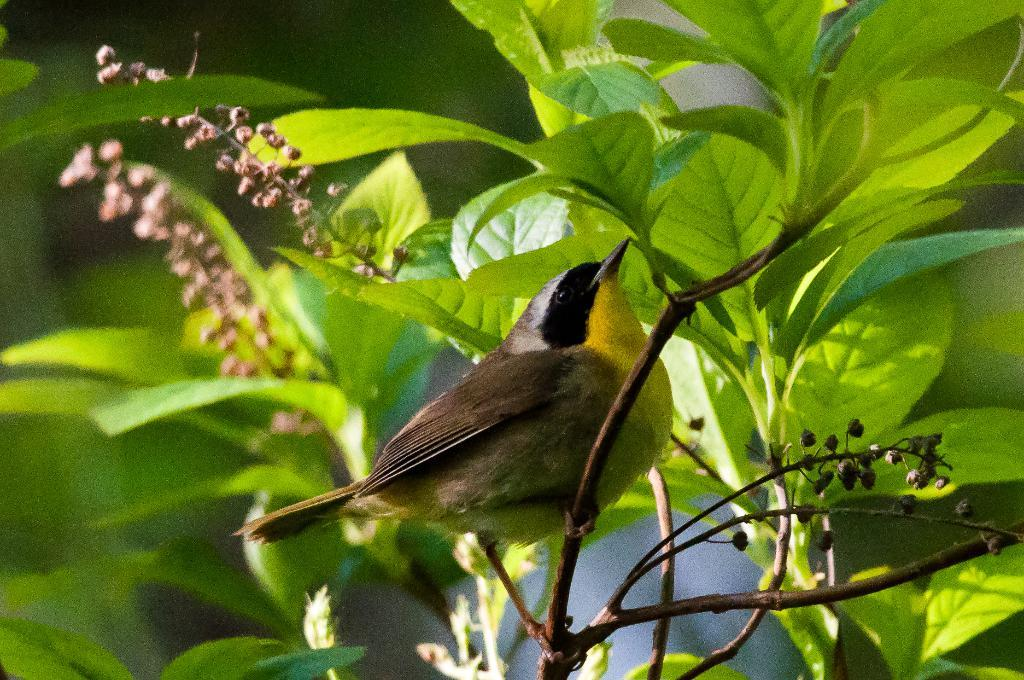What is located in the center of the image? There are plants in the center of the image. What can be seen on the plants in the image? There is a bird on a branch. What colors can be observed on the bird? The bird has black, brown, and yellow colors. How would you describe the background of the image? The background of the image is blurred. Can you tell me how many cables are hanging from the bird's beak in the image? There are no cables present in the image; the bird is on a branch with no visible cables. 